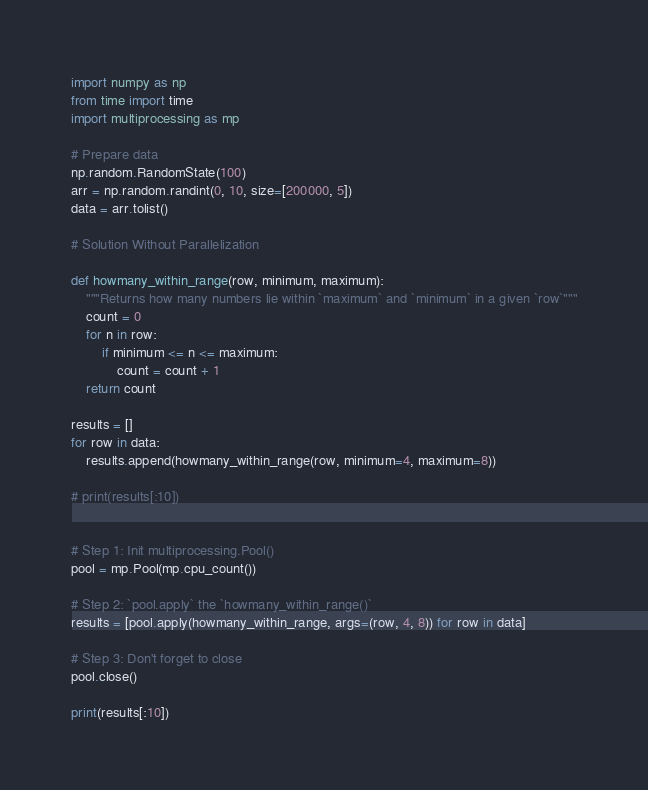Convert code to text. <code><loc_0><loc_0><loc_500><loc_500><_Python_>import numpy as np
from time import time
import multiprocessing as mp

# Prepare data
np.random.RandomState(100)
arr = np.random.randint(0, 10, size=[200000, 5])
data = arr.tolist()

# Solution Without Parallelization

def howmany_within_range(row, minimum, maximum):
    """Returns how many numbers lie within `maximum` and `minimum` in a given `row`"""
    count = 0
    for n in row:
        if minimum <= n <= maximum:
            count = count + 1
    return count

results = []
for row in data:
    results.append(howmany_within_range(row, minimum=4, maximum=8))

# print(results[:10])


# Step 1: Init multiprocessing.Pool()
pool = mp.Pool(mp.cpu_count())

# Step 2: `pool.apply` the `howmany_within_range()`
results = [pool.apply(howmany_within_range, args=(row, 4, 8)) for row in data]

# Step 3: Don't forget to close
pool.close()

print(results[:10])

</code> 